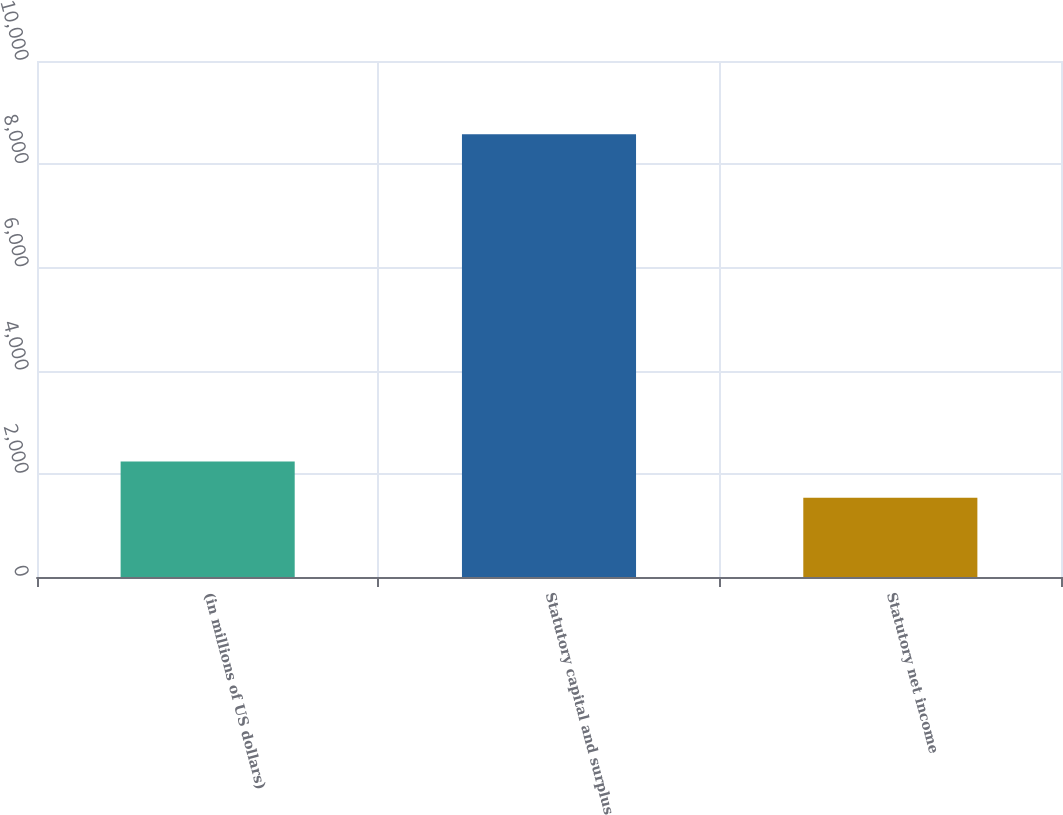Convert chart. <chart><loc_0><loc_0><loc_500><loc_500><bar_chart><fcel>(in millions of US dollars)<fcel>Statutory capital and surplus<fcel>Statutory net income<nl><fcel>2239.4<fcel>8579<fcel>1535<nl></chart> 